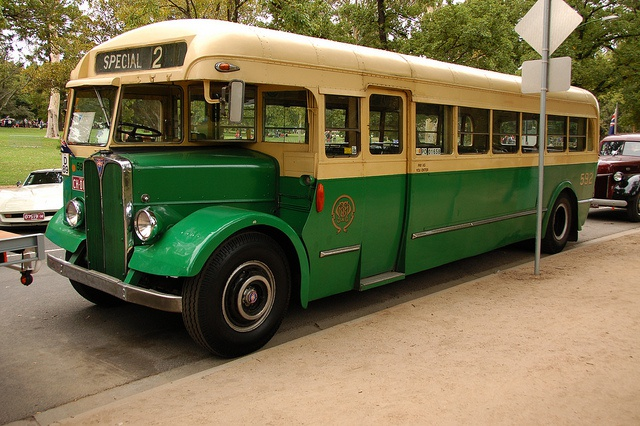Describe the objects in this image and their specific colors. I can see bus in olive, black, darkgreen, and tan tones, car in olive, black, darkgray, gray, and maroon tones, and car in olive, ivory, black, and darkgray tones in this image. 